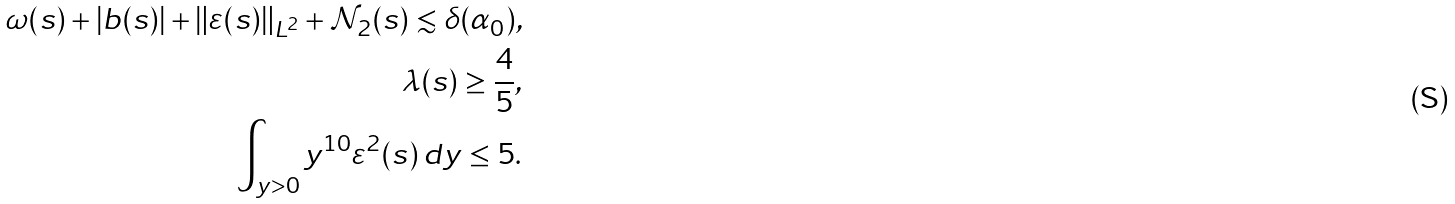Convert formula to latex. <formula><loc_0><loc_0><loc_500><loc_500>\omega ( s ) + | b ( s ) | + \| \varepsilon ( s ) \| _ { L ^ { 2 } } + \mathcal { N } _ { 2 } ( s ) \lesssim \delta ( \alpha _ { 0 } ) , \\ \lambda ( s ) \geq \frac { 4 } { 5 } , \\ \int _ { y > 0 } y ^ { 1 0 } \varepsilon ^ { 2 } ( s ) \, d y \leq 5 .</formula> 